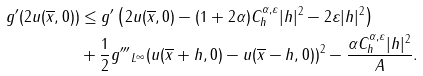<formula> <loc_0><loc_0><loc_500><loc_500>g ^ { \prime } ( 2 u ( \overline { x } , 0 ) ) & \leq g ^ { \prime } \left ( 2 u ( \overline { x } , 0 ) - ( 1 + 2 \alpha ) C ^ { \alpha , \varepsilon } _ { h } | h | ^ { 2 } - 2 \varepsilon | h | ^ { 2 } \right ) \\ & + \frac { 1 } { 2 } \| g ^ { \prime \prime \prime } \| _ { L ^ { \infty } } ( u ( \overline { x } + h , 0 ) - u ( \overline { x } - h , 0 ) ) ^ { 2 } - \frac { \alpha C ^ { \alpha , \varepsilon } _ { h } | h | ^ { 2 } } { A } .</formula> 